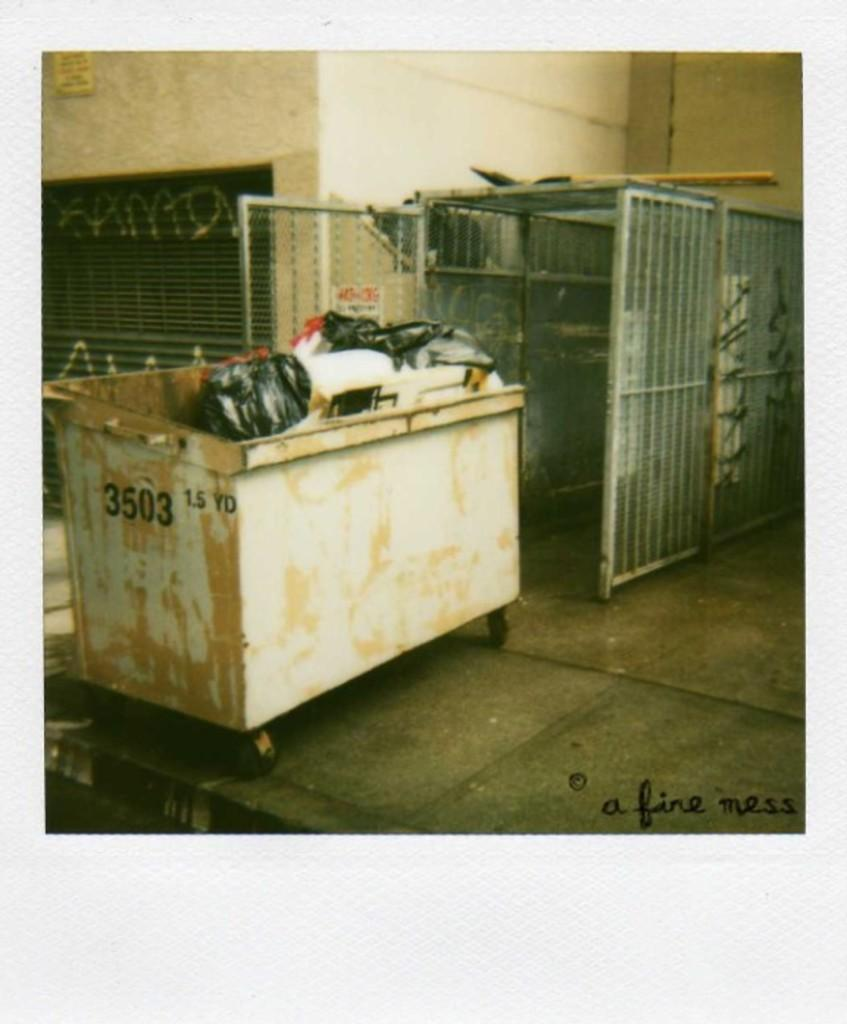<image>
Summarize the visual content of the image. A warehouse that has a garbage dumpster full of garbage and the words a fine mess written in the cement floor. 